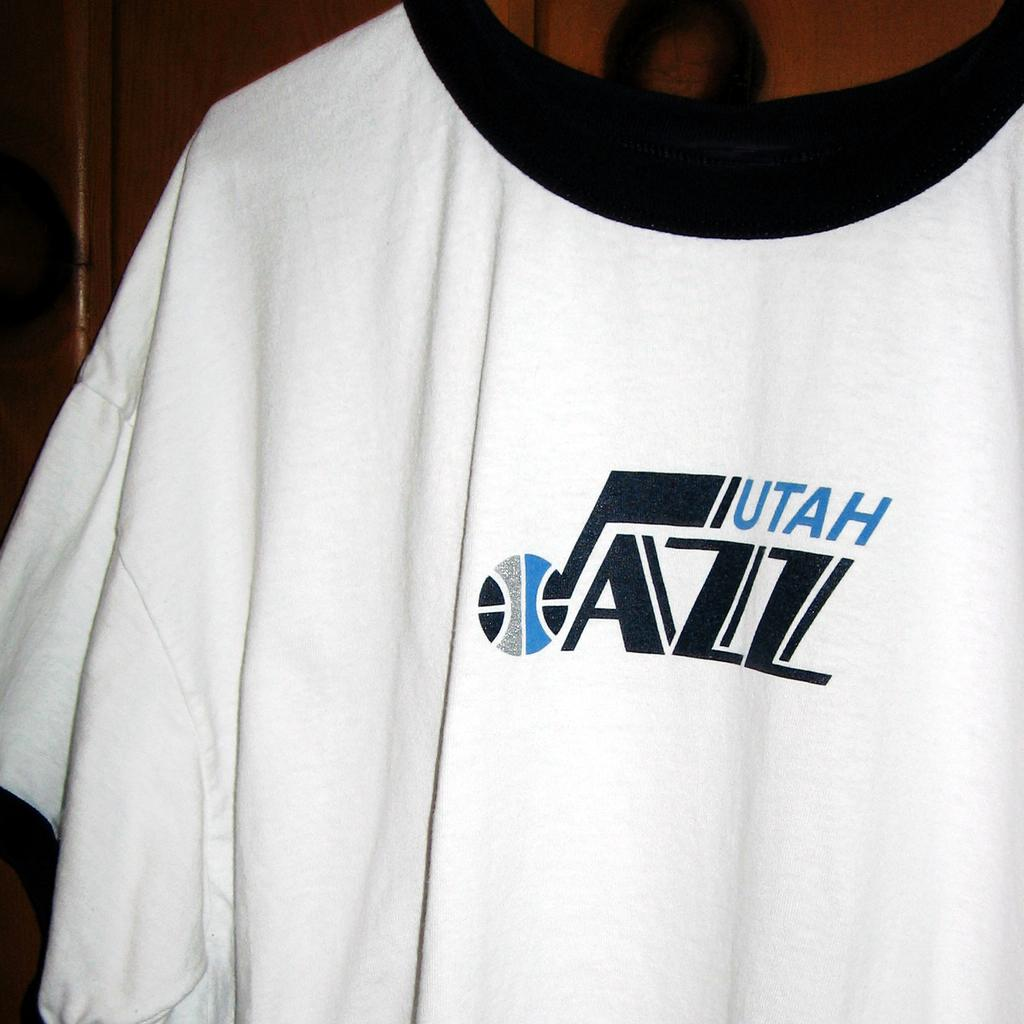<image>
Present a compact description of the photo's key features. A t-shirt with a logo for a Utah ball team. 